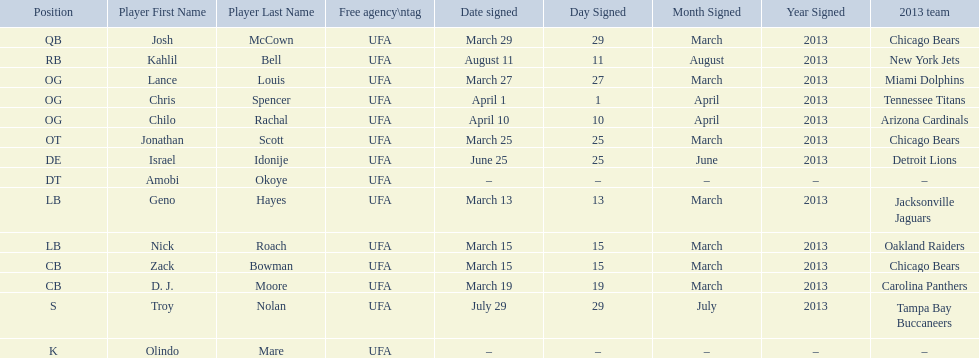Geno hayes and nick roach both played which position? LB. 